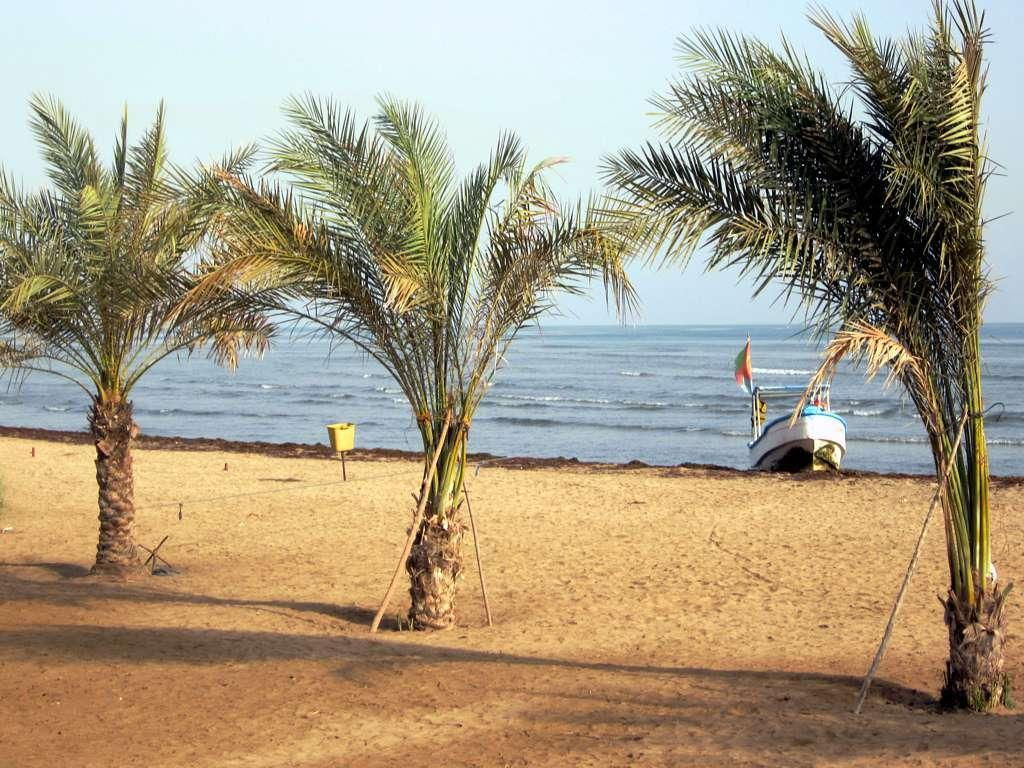What type of vegetation can be seen in the image? There are trees in the image. What type of terrain is visible in the image? There is sand in the image. What type of vehicle is present in the image? There is a boat in the image. What natural element is visible in the image? There is water visible in the image. What is visible in the background of the image? The sky is visible in the image. What type of reaction can be seen on the sofa in the image? There is no sofa present in the image, and therefore no reaction can be observed. Can you describe the man sitting on the boat in the image? There is no man present in the image, only a boat. 